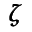Convert formula to latex. <formula><loc_0><loc_0><loc_500><loc_500>\pm b { \zeta }</formula> 